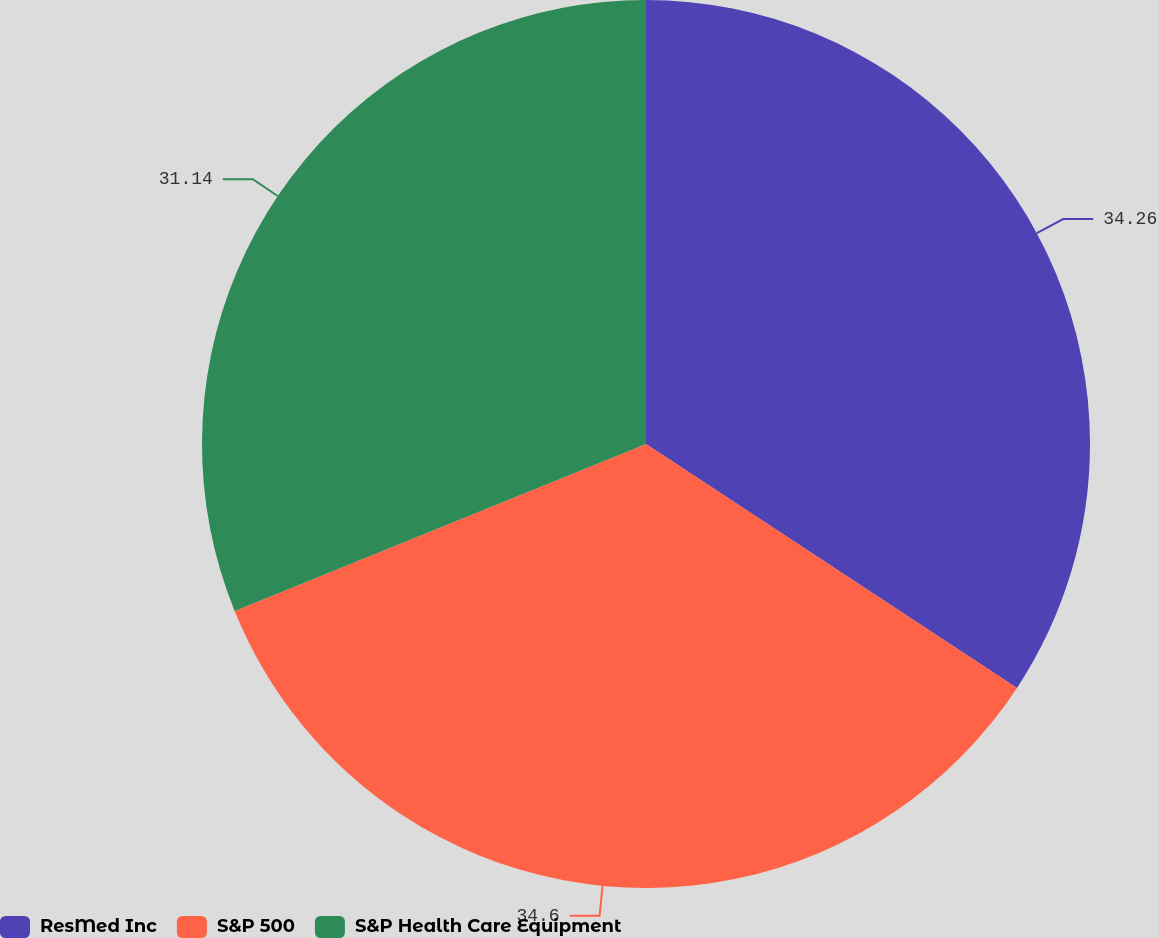Convert chart to OTSL. <chart><loc_0><loc_0><loc_500><loc_500><pie_chart><fcel>ResMed Inc<fcel>S&P 500<fcel>S&P Health Care Equipment<nl><fcel>34.26%<fcel>34.61%<fcel>31.14%<nl></chart> 